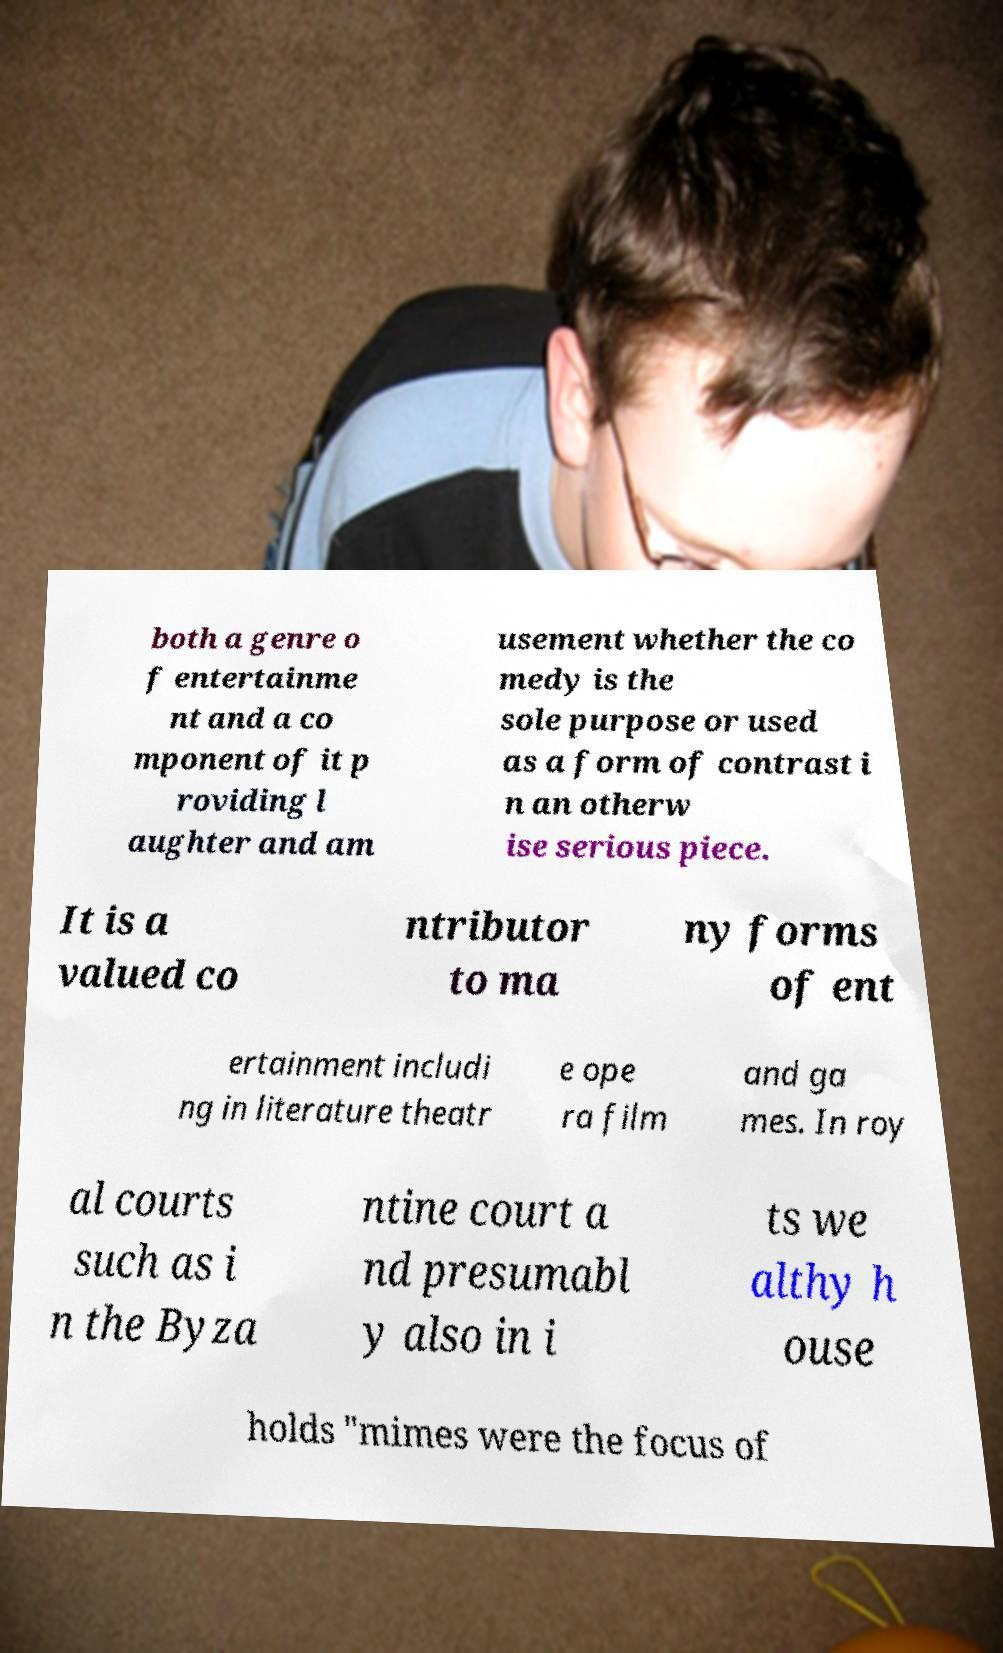For documentation purposes, I need the text within this image transcribed. Could you provide that? both a genre o f entertainme nt and a co mponent of it p roviding l aughter and am usement whether the co medy is the sole purpose or used as a form of contrast i n an otherw ise serious piece. It is a valued co ntributor to ma ny forms of ent ertainment includi ng in literature theatr e ope ra film and ga mes. In roy al courts such as i n the Byza ntine court a nd presumabl y also in i ts we althy h ouse holds "mimes were the focus of 